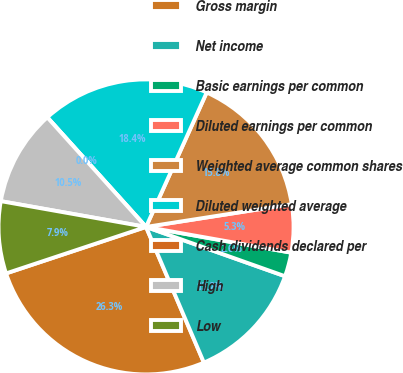Convert chart. <chart><loc_0><loc_0><loc_500><loc_500><pie_chart><fcel>Gross margin<fcel>Net income<fcel>Basic earnings per common<fcel>Diluted earnings per common<fcel>Weighted average common shares<fcel>Diluted weighted average<fcel>Cash dividends declared per<fcel>High<fcel>Low<nl><fcel>26.31%<fcel>13.16%<fcel>2.63%<fcel>5.26%<fcel>15.79%<fcel>18.42%<fcel>0.0%<fcel>10.53%<fcel>7.9%<nl></chart> 